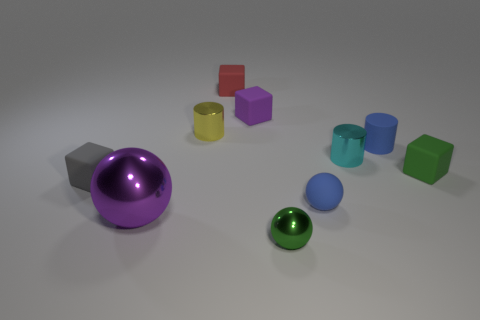Subtract 1 spheres. How many spheres are left? 2 Subtract all brown blocks. Subtract all red cylinders. How many blocks are left? 4 Subtract all balls. How many objects are left? 7 Subtract 0 cyan balls. How many objects are left? 10 Subtract all small shiny objects. Subtract all tiny blue rubber cylinders. How many objects are left? 6 Add 4 purple rubber things. How many purple rubber things are left? 5 Add 7 small purple objects. How many small purple objects exist? 8 